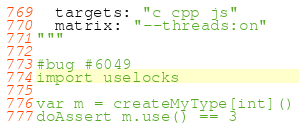<code> <loc_0><loc_0><loc_500><loc_500><_Nim_>  targets: "c cpp js"
  matrix: "--threads:on"
"""

#bug #6049
import uselocks

var m = createMyType[int]()
doAssert m.use() == 3
</code> 